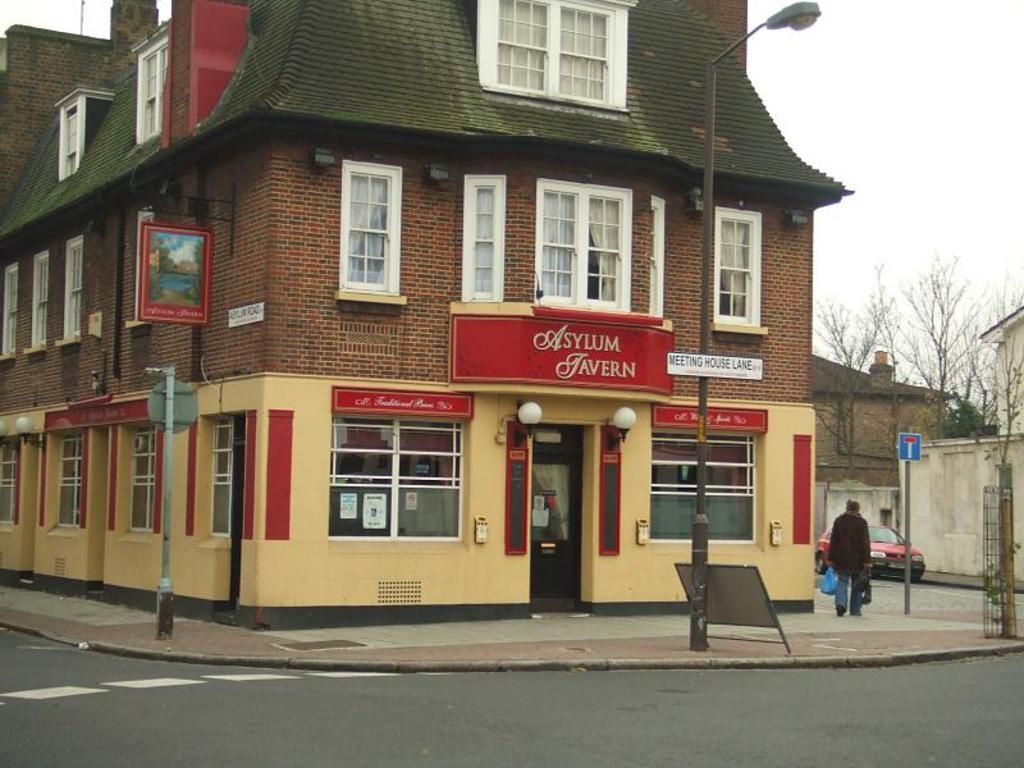Where was the image taken? The image was taken on a road. What can be seen in the background of the image? There is a brown building in the background of the image. What is present in the image besides the road and the building? There is a poster in the image. What does the poster say? The poster has "Asylum Javern" written on it. How does the wealth of the people in the image affect the quality of the poster? There is no information about the wealth of the people in the image, and the quality of the poster is not related to their wealth. 